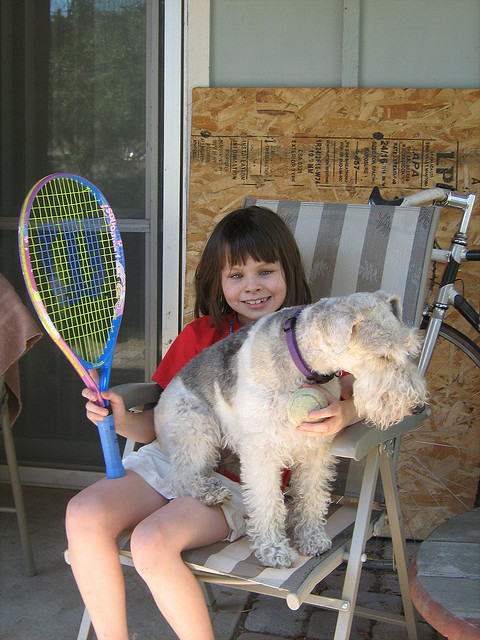Please transcribe the text in this image. LP APA 